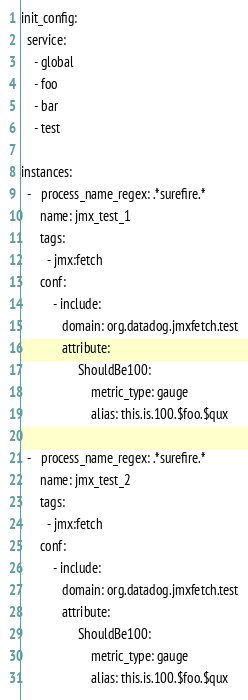Convert code to text. <code><loc_0><loc_0><loc_500><loc_500><_YAML_>init_config:
  service:
    - global
    - foo
    - bar
    - test

instances:
  -   process_name_regex: .*surefire.*
      name: jmx_test_1
      tags:
        - jmx:fetch
      conf:
          - include:
             domain: org.datadog.jmxfetch.test
             attribute:
                  ShouldBe100:
                      metric_type: gauge
                      alias: this.is.100.$foo.$qux

  -   process_name_regex: .*surefire.*
      name: jmx_test_2
      tags:
        - jmx:fetch
      conf:
          - include:
             domain: org.datadog.jmxfetch.test
             attribute:
                  ShouldBe100:
                      metric_type: gauge
                      alias: this.is.100.$foo.$qux
</code> 